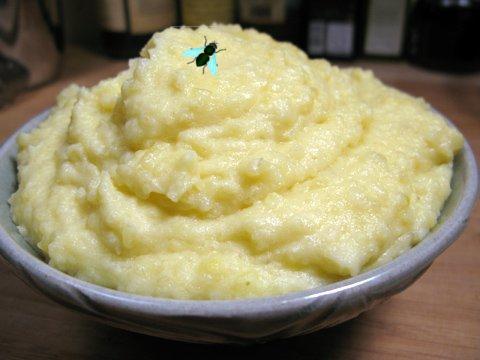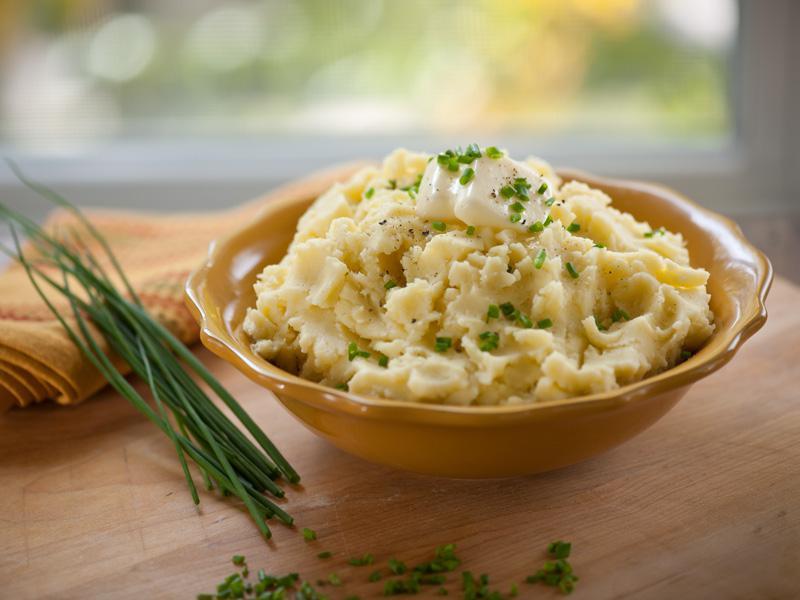The first image is the image on the left, the second image is the image on the right. For the images displayed, is the sentence "The right hand dish has slightly fluted edges." factually correct? Answer yes or no. Yes. 